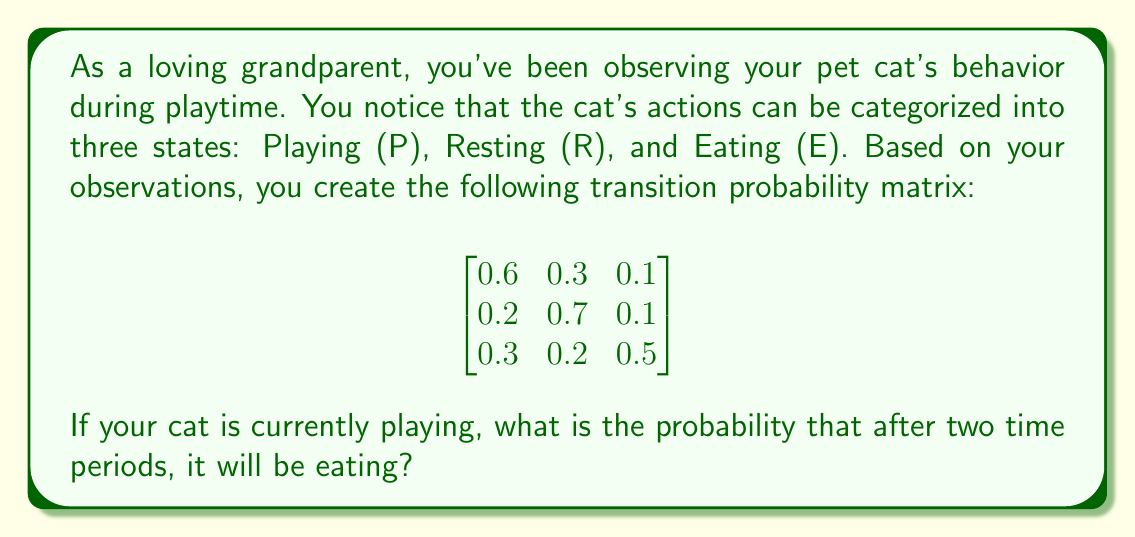Could you help me with this problem? To solve this problem, we'll use the Markov chain and matrix multiplication. Let's approach this step-by-step:

1) The given transition probability matrix $P$ represents the probabilities of moving from one state to another in a single time period. The rows represent the current state, and the columns represent the next state, in the order Playing (P), Resting (R), and Eating (E).

2) We want to find the probability of the cat eating after two time periods, given that it starts playing. This means we need to calculate $P^2$ (the matrix multiplied by itself).

3) Let's perform the matrix multiplication:

   $$P^2 = \begin{bmatrix}
   0.6 & 0.3 & 0.1 \\
   0.2 & 0.7 & 0.1 \\
   0.3 & 0.2 & 0.5
   \end{bmatrix} \times 
   \begin{bmatrix}
   0.6 & 0.3 & 0.1 \\
   0.2 & 0.7 & 0.1 \\
   0.3 & 0.2 & 0.5
   \end{bmatrix}$$

4) Calculating the first row of the resulting matrix (as we're interested in starting from the Playing state):

   $$(0.6 \times 0.6 + 0.3 \times 0.2 + 0.1 \times 0.3) = 0.46$$
   $$(0.6 \times 0.3 + 0.3 \times 0.7 + 0.1 \times 0.2) = 0.40$$
   $$(0.6 \times 0.1 + 0.3 \times 0.1 + 0.1 \times 0.5) = 0.14$$

5) The resulting first row of $P^2$ is $[0.46, 0.40, 0.14]$.

6) We're interested in the probability of eating after two time periods, which is the last element of this row: 0.14 or 14%.
Answer: 0.14 